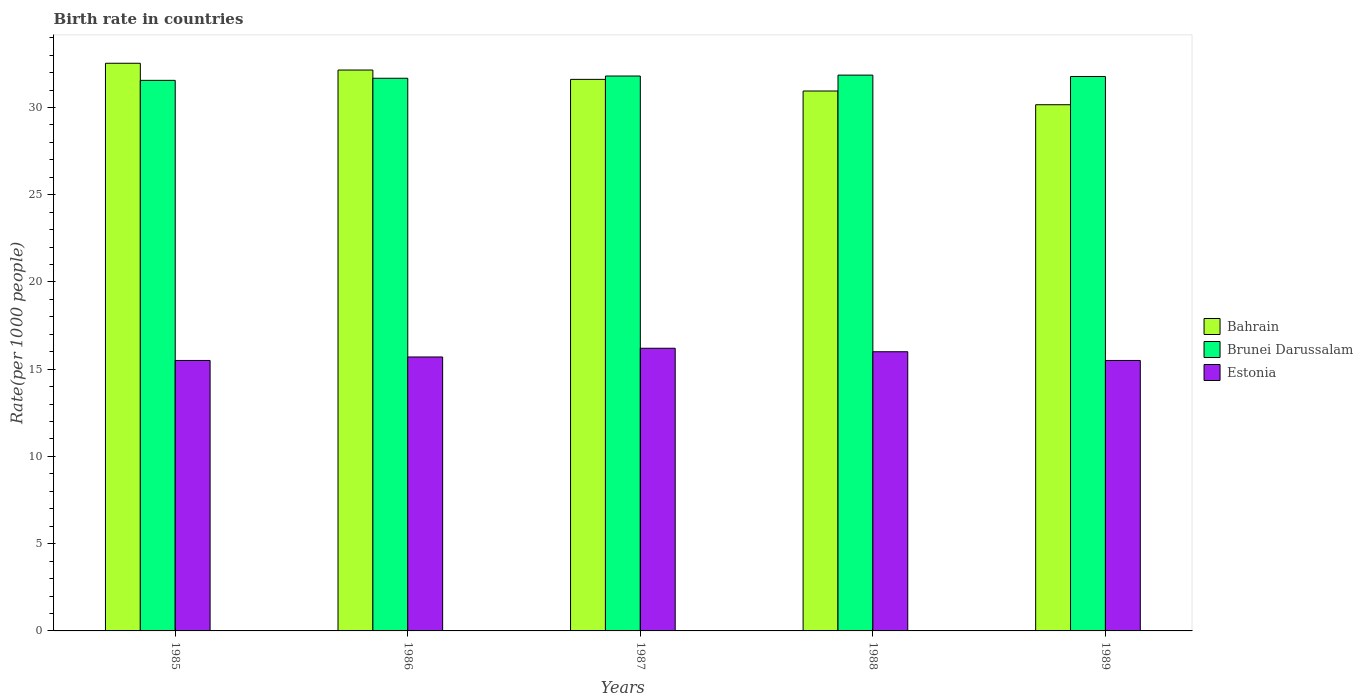How many bars are there on the 5th tick from the right?
Provide a succinct answer. 3. Across all years, what is the maximum birth rate in Brunei Darussalam?
Offer a terse response. 31.85. In which year was the birth rate in Bahrain minimum?
Make the answer very short. 1989. What is the total birth rate in Brunei Darussalam in the graph?
Offer a terse response. 158.65. What is the difference between the birth rate in Estonia in 1985 and that in 1986?
Offer a terse response. -0.2. What is the difference between the birth rate in Bahrain in 1986 and the birth rate in Brunei Darussalam in 1985?
Provide a short and direct response. 0.59. What is the average birth rate in Estonia per year?
Ensure brevity in your answer.  15.78. In the year 1988, what is the difference between the birth rate in Bahrain and birth rate in Brunei Darussalam?
Make the answer very short. -0.91. In how many years, is the birth rate in Estonia greater than 11?
Provide a short and direct response. 5. What is the ratio of the birth rate in Estonia in 1987 to that in 1989?
Provide a short and direct response. 1.05. Is the birth rate in Bahrain in 1987 less than that in 1989?
Your response must be concise. No. What is the difference between the highest and the second highest birth rate in Bahrain?
Your answer should be very brief. 0.39. What is the difference between the highest and the lowest birth rate in Brunei Darussalam?
Keep it short and to the point. 0.3. In how many years, is the birth rate in Brunei Darussalam greater than the average birth rate in Brunei Darussalam taken over all years?
Offer a very short reply. 3. Is the sum of the birth rate in Bahrain in 1986 and 1988 greater than the maximum birth rate in Brunei Darussalam across all years?
Make the answer very short. Yes. What does the 2nd bar from the left in 1987 represents?
Offer a terse response. Brunei Darussalam. What does the 3rd bar from the right in 1989 represents?
Offer a very short reply. Bahrain. Is it the case that in every year, the sum of the birth rate in Brunei Darussalam and birth rate in Bahrain is greater than the birth rate in Estonia?
Ensure brevity in your answer.  Yes. How many bars are there?
Your answer should be very brief. 15. How many years are there in the graph?
Your response must be concise. 5. Does the graph contain any zero values?
Provide a succinct answer. No. Does the graph contain grids?
Ensure brevity in your answer.  No. Where does the legend appear in the graph?
Provide a short and direct response. Center right. How many legend labels are there?
Ensure brevity in your answer.  3. How are the legend labels stacked?
Offer a terse response. Vertical. What is the title of the graph?
Your answer should be very brief. Birth rate in countries. What is the label or title of the Y-axis?
Offer a very short reply. Rate(per 1000 people). What is the Rate(per 1000 people) of Bahrain in 1985?
Provide a succinct answer. 32.53. What is the Rate(per 1000 people) in Brunei Darussalam in 1985?
Offer a very short reply. 31.55. What is the Rate(per 1000 people) in Bahrain in 1986?
Offer a very short reply. 32.14. What is the Rate(per 1000 people) of Brunei Darussalam in 1986?
Your answer should be compact. 31.67. What is the Rate(per 1000 people) in Estonia in 1986?
Ensure brevity in your answer.  15.7. What is the Rate(per 1000 people) of Bahrain in 1987?
Make the answer very short. 31.61. What is the Rate(per 1000 people) in Brunei Darussalam in 1987?
Your response must be concise. 31.8. What is the Rate(per 1000 people) of Bahrain in 1988?
Provide a short and direct response. 30.94. What is the Rate(per 1000 people) in Brunei Darussalam in 1988?
Your answer should be compact. 31.85. What is the Rate(per 1000 people) in Bahrain in 1989?
Offer a terse response. 30.16. What is the Rate(per 1000 people) of Brunei Darussalam in 1989?
Offer a very short reply. 31.77. Across all years, what is the maximum Rate(per 1000 people) of Bahrain?
Your response must be concise. 32.53. Across all years, what is the maximum Rate(per 1000 people) in Brunei Darussalam?
Ensure brevity in your answer.  31.85. Across all years, what is the maximum Rate(per 1000 people) of Estonia?
Offer a terse response. 16.2. Across all years, what is the minimum Rate(per 1000 people) in Bahrain?
Provide a short and direct response. 30.16. Across all years, what is the minimum Rate(per 1000 people) in Brunei Darussalam?
Your response must be concise. 31.55. Across all years, what is the minimum Rate(per 1000 people) in Estonia?
Your response must be concise. 15.5. What is the total Rate(per 1000 people) of Bahrain in the graph?
Make the answer very short. 157.39. What is the total Rate(per 1000 people) of Brunei Darussalam in the graph?
Provide a short and direct response. 158.65. What is the total Rate(per 1000 people) in Estonia in the graph?
Give a very brief answer. 78.9. What is the difference between the Rate(per 1000 people) of Bahrain in 1985 and that in 1986?
Your response must be concise. 0.39. What is the difference between the Rate(per 1000 people) of Brunei Darussalam in 1985 and that in 1986?
Provide a short and direct response. -0.12. What is the difference between the Rate(per 1000 people) in Bahrain in 1985 and that in 1987?
Your answer should be very brief. 0.92. What is the difference between the Rate(per 1000 people) of Brunei Darussalam in 1985 and that in 1987?
Offer a very short reply. -0.25. What is the difference between the Rate(per 1000 people) in Estonia in 1985 and that in 1987?
Make the answer very short. -0.7. What is the difference between the Rate(per 1000 people) of Bahrain in 1985 and that in 1988?
Make the answer very short. 1.59. What is the difference between the Rate(per 1000 people) in Brunei Darussalam in 1985 and that in 1988?
Provide a succinct answer. -0.3. What is the difference between the Rate(per 1000 people) of Bahrain in 1985 and that in 1989?
Make the answer very short. 2.38. What is the difference between the Rate(per 1000 people) in Brunei Darussalam in 1985 and that in 1989?
Offer a very short reply. -0.22. What is the difference between the Rate(per 1000 people) in Bahrain in 1986 and that in 1987?
Make the answer very short. 0.53. What is the difference between the Rate(per 1000 people) in Brunei Darussalam in 1986 and that in 1987?
Offer a terse response. -0.13. What is the difference between the Rate(per 1000 people) of Estonia in 1986 and that in 1987?
Your answer should be compact. -0.5. What is the difference between the Rate(per 1000 people) of Bahrain in 1986 and that in 1988?
Your answer should be very brief. 1.2. What is the difference between the Rate(per 1000 people) in Brunei Darussalam in 1986 and that in 1988?
Offer a very short reply. -0.18. What is the difference between the Rate(per 1000 people) of Bahrain in 1986 and that in 1989?
Make the answer very short. 1.99. What is the difference between the Rate(per 1000 people) in Brunei Darussalam in 1986 and that in 1989?
Keep it short and to the point. -0.1. What is the difference between the Rate(per 1000 people) of Estonia in 1986 and that in 1989?
Your answer should be compact. 0.2. What is the difference between the Rate(per 1000 people) in Bahrain in 1987 and that in 1988?
Your answer should be compact. 0.67. What is the difference between the Rate(per 1000 people) in Brunei Darussalam in 1987 and that in 1988?
Ensure brevity in your answer.  -0.05. What is the difference between the Rate(per 1000 people) of Estonia in 1987 and that in 1988?
Make the answer very short. 0.2. What is the difference between the Rate(per 1000 people) in Bahrain in 1987 and that in 1989?
Ensure brevity in your answer.  1.45. What is the difference between the Rate(per 1000 people) of Brunei Darussalam in 1987 and that in 1989?
Your answer should be compact. 0.03. What is the difference between the Rate(per 1000 people) in Estonia in 1987 and that in 1989?
Offer a terse response. 0.7. What is the difference between the Rate(per 1000 people) in Bahrain in 1988 and that in 1989?
Provide a short and direct response. 0.79. What is the difference between the Rate(per 1000 people) of Brunei Darussalam in 1988 and that in 1989?
Provide a succinct answer. 0.08. What is the difference between the Rate(per 1000 people) in Estonia in 1988 and that in 1989?
Your answer should be compact. 0.5. What is the difference between the Rate(per 1000 people) of Bahrain in 1985 and the Rate(per 1000 people) of Brunei Darussalam in 1986?
Offer a very short reply. 0.86. What is the difference between the Rate(per 1000 people) of Bahrain in 1985 and the Rate(per 1000 people) of Estonia in 1986?
Keep it short and to the point. 16.83. What is the difference between the Rate(per 1000 people) of Brunei Darussalam in 1985 and the Rate(per 1000 people) of Estonia in 1986?
Your answer should be compact. 15.85. What is the difference between the Rate(per 1000 people) of Bahrain in 1985 and the Rate(per 1000 people) of Brunei Darussalam in 1987?
Keep it short and to the point. 0.73. What is the difference between the Rate(per 1000 people) in Bahrain in 1985 and the Rate(per 1000 people) in Estonia in 1987?
Offer a very short reply. 16.33. What is the difference between the Rate(per 1000 people) of Brunei Darussalam in 1985 and the Rate(per 1000 people) of Estonia in 1987?
Ensure brevity in your answer.  15.35. What is the difference between the Rate(per 1000 people) in Bahrain in 1985 and the Rate(per 1000 people) in Brunei Darussalam in 1988?
Offer a terse response. 0.68. What is the difference between the Rate(per 1000 people) in Bahrain in 1985 and the Rate(per 1000 people) in Estonia in 1988?
Offer a terse response. 16.53. What is the difference between the Rate(per 1000 people) of Brunei Darussalam in 1985 and the Rate(per 1000 people) of Estonia in 1988?
Give a very brief answer. 15.55. What is the difference between the Rate(per 1000 people) in Bahrain in 1985 and the Rate(per 1000 people) in Brunei Darussalam in 1989?
Ensure brevity in your answer.  0.76. What is the difference between the Rate(per 1000 people) in Bahrain in 1985 and the Rate(per 1000 people) in Estonia in 1989?
Provide a succinct answer. 17.03. What is the difference between the Rate(per 1000 people) in Brunei Darussalam in 1985 and the Rate(per 1000 people) in Estonia in 1989?
Provide a succinct answer. 16.05. What is the difference between the Rate(per 1000 people) of Bahrain in 1986 and the Rate(per 1000 people) of Brunei Darussalam in 1987?
Make the answer very short. 0.34. What is the difference between the Rate(per 1000 people) of Bahrain in 1986 and the Rate(per 1000 people) of Estonia in 1987?
Offer a very short reply. 15.94. What is the difference between the Rate(per 1000 people) of Brunei Darussalam in 1986 and the Rate(per 1000 people) of Estonia in 1987?
Offer a terse response. 15.47. What is the difference between the Rate(per 1000 people) in Bahrain in 1986 and the Rate(per 1000 people) in Brunei Darussalam in 1988?
Ensure brevity in your answer.  0.29. What is the difference between the Rate(per 1000 people) in Bahrain in 1986 and the Rate(per 1000 people) in Estonia in 1988?
Your response must be concise. 16.14. What is the difference between the Rate(per 1000 people) in Brunei Darussalam in 1986 and the Rate(per 1000 people) in Estonia in 1988?
Your answer should be compact. 15.67. What is the difference between the Rate(per 1000 people) of Bahrain in 1986 and the Rate(per 1000 people) of Brunei Darussalam in 1989?
Give a very brief answer. 0.37. What is the difference between the Rate(per 1000 people) of Bahrain in 1986 and the Rate(per 1000 people) of Estonia in 1989?
Your answer should be very brief. 16.64. What is the difference between the Rate(per 1000 people) in Brunei Darussalam in 1986 and the Rate(per 1000 people) in Estonia in 1989?
Your response must be concise. 16.17. What is the difference between the Rate(per 1000 people) in Bahrain in 1987 and the Rate(per 1000 people) in Brunei Darussalam in 1988?
Offer a terse response. -0.24. What is the difference between the Rate(per 1000 people) in Bahrain in 1987 and the Rate(per 1000 people) in Estonia in 1988?
Your answer should be very brief. 15.61. What is the difference between the Rate(per 1000 people) of Brunei Darussalam in 1987 and the Rate(per 1000 people) of Estonia in 1988?
Provide a short and direct response. 15.8. What is the difference between the Rate(per 1000 people) in Bahrain in 1987 and the Rate(per 1000 people) in Brunei Darussalam in 1989?
Give a very brief answer. -0.16. What is the difference between the Rate(per 1000 people) in Bahrain in 1987 and the Rate(per 1000 people) in Estonia in 1989?
Make the answer very short. 16.11. What is the difference between the Rate(per 1000 people) in Brunei Darussalam in 1987 and the Rate(per 1000 people) in Estonia in 1989?
Offer a terse response. 16.3. What is the difference between the Rate(per 1000 people) in Bahrain in 1988 and the Rate(per 1000 people) in Brunei Darussalam in 1989?
Keep it short and to the point. -0.83. What is the difference between the Rate(per 1000 people) in Bahrain in 1988 and the Rate(per 1000 people) in Estonia in 1989?
Your response must be concise. 15.44. What is the difference between the Rate(per 1000 people) in Brunei Darussalam in 1988 and the Rate(per 1000 people) in Estonia in 1989?
Your answer should be compact. 16.35. What is the average Rate(per 1000 people) of Bahrain per year?
Give a very brief answer. 31.48. What is the average Rate(per 1000 people) of Brunei Darussalam per year?
Your answer should be compact. 31.73. What is the average Rate(per 1000 people) of Estonia per year?
Your answer should be very brief. 15.78. In the year 1985, what is the difference between the Rate(per 1000 people) in Bahrain and Rate(per 1000 people) in Estonia?
Ensure brevity in your answer.  17.03. In the year 1985, what is the difference between the Rate(per 1000 people) in Brunei Darussalam and Rate(per 1000 people) in Estonia?
Provide a succinct answer. 16.05. In the year 1986, what is the difference between the Rate(per 1000 people) of Bahrain and Rate(per 1000 people) of Brunei Darussalam?
Keep it short and to the point. 0.47. In the year 1986, what is the difference between the Rate(per 1000 people) of Bahrain and Rate(per 1000 people) of Estonia?
Provide a succinct answer. 16.44. In the year 1986, what is the difference between the Rate(per 1000 people) of Brunei Darussalam and Rate(per 1000 people) of Estonia?
Ensure brevity in your answer.  15.97. In the year 1987, what is the difference between the Rate(per 1000 people) in Bahrain and Rate(per 1000 people) in Brunei Darussalam?
Ensure brevity in your answer.  -0.19. In the year 1987, what is the difference between the Rate(per 1000 people) in Bahrain and Rate(per 1000 people) in Estonia?
Offer a terse response. 15.41. In the year 1987, what is the difference between the Rate(per 1000 people) of Brunei Darussalam and Rate(per 1000 people) of Estonia?
Make the answer very short. 15.6. In the year 1988, what is the difference between the Rate(per 1000 people) of Bahrain and Rate(per 1000 people) of Brunei Darussalam?
Offer a very short reply. -0.91. In the year 1988, what is the difference between the Rate(per 1000 people) in Bahrain and Rate(per 1000 people) in Estonia?
Provide a short and direct response. 14.94. In the year 1988, what is the difference between the Rate(per 1000 people) in Brunei Darussalam and Rate(per 1000 people) in Estonia?
Give a very brief answer. 15.85. In the year 1989, what is the difference between the Rate(per 1000 people) of Bahrain and Rate(per 1000 people) of Brunei Darussalam?
Your answer should be compact. -1.62. In the year 1989, what is the difference between the Rate(per 1000 people) in Bahrain and Rate(per 1000 people) in Estonia?
Keep it short and to the point. 14.66. In the year 1989, what is the difference between the Rate(per 1000 people) in Brunei Darussalam and Rate(per 1000 people) in Estonia?
Keep it short and to the point. 16.27. What is the ratio of the Rate(per 1000 people) in Bahrain in 1985 to that in 1986?
Your response must be concise. 1.01. What is the ratio of the Rate(per 1000 people) in Estonia in 1985 to that in 1986?
Your answer should be compact. 0.99. What is the ratio of the Rate(per 1000 people) in Bahrain in 1985 to that in 1987?
Your answer should be very brief. 1.03. What is the ratio of the Rate(per 1000 people) in Brunei Darussalam in 1985 to that in 1987?
Make the answer very short. 0.99. What is the ratio of the Rate(per 1000 people) in Estonia in 1985 to that in 1987?
Make the answer very short. 0.96. What is the ratio of the Rate(per 1000 people) of Bahrain in 1985 to that in 1988?
Offer a very short reply. 1.05. What is the ratio of the Rate(per 1000 people) in Brunei Darussalam in 1985 to that in 1988?
Give a very brief answer. 0.99. What is the ratio of the Rate(per 1000 people) of Estonia in 1985 to that in 1988?
Your answer should be compact. 0.97. What is the ratio of the Rate(per 1000 people) of Bahrain in 1985 to that in 1989?
Offer a very short reply. 1.08. What is the ratio of the Rate(per 1000 people) of Estonia in 1985 to that in 1989?
Make the answer very short. 1. What is the ratio of the Rate(per 1000 people) of Bahrain in 1986 to that in 1987?
Provide a succinct answer. 1.02. What is the ratio of the Rate(per 1000 people) in Brunei Darussalam in 1986 to that in 1987?
Your answer should be compact. 1. What is the ratio of the Rate(per 1000 people) of Estonia in 1986 to that in 1987?
Provide a short and direct response. 0.97. What is the ratio of the Rate(per 1000 people) of Bahrain in 1986 to that in 1988?
Offer a very short reply. 1.04. What is the ratio of the Rate(per 1000 people) of Estonia in 1986 to that in 1988?
Your response must be concise. 0.98. What is the ratio of the Rate(per 1000 people) of Bahrain in 1986 to that in 1989?
Make the answer very short. 1.07. What is the ratio of the Rate(per 1000 people) of Brunei Darussalam in 1986 to that in 1989?
Your answer should be very brief. 1. What is the ratio of the Rate(per 1000 people) in Estonia in 1986 to that in 1989?
Give a very brief answer. 1.01. What is the ratio of the Rate(per 1000 people) of Bahrain in 1987 to that in 1988?
Ensure brevity in your answer.  1.02. What is the ratio of the Rate(per 1000 people) in Brunei Darussalam in 1987 to that in 1988?
Keep it short and to the point. 1. What is the ratio of the Rate(per 1000 people) of Estonia in 1987 to that in 1988?
Make the answer very short. 1.01. What is the ratio of the Rate(per 1000 people) of Bahrain in 1987 to that in 1989?
Make the answer very short. 1.05. What is the ratio of the Rate(per 1000 people) of Estonia in 1987 to that in 1989?
Provide a succinct answer. 1.05. What is the ratio of the Rate(per 1000 people) in Bahrain in 1988 to that in 1989?
Your response must be concise. 1.03. What is the ratio of the Rate(per 1000 people) of Brunei Darussalam in 1988 to that in 1989?
Give a very brief answer. 1. What is the ratio of the Rate(per 1000 people) of Estonia in 1988 to that in 1989?
Provide a succinct answer. 1.03. What is the difference between the highest and the second highest Rate(per 1000 people) of Bahrain?
Provide a short and direct response. 0.39. What is the difference between the highest and the second highest Rate(per 1000 people) in Brunei Darussalam?
Make the answer very short. 0.05. What is the difference between the highest and the lowest Rate(per 1000 people) in Bahrain?
Offer a very short reply. 2.38. What is the difference between the highest and the lowest Rate(per 1000 people) in Estonia?
Ensure brevity in your answer.  0.7. 